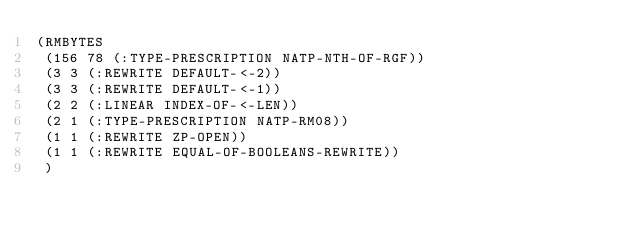Convert code to text. <code><loc_0><loc_0><loc_500><loc_500><_Lisp_>(RMBYTES
 (156 78 (:TYPE-PRESCRIPTION NATP-NTH-OF-RGF))
 (3 3 (:REWRITE DEFAULT-<-2))
 (3 3 (:REWRITE DEFAULT-<-1))
 (2 2 (:LINEAR INDEX-OF-<-LEN))
 (2 1 (:TYPE-PRESCRIPTION NATP-RM08))
 (1 1 (:REWRITE ZP-OPEN))
 (1 1 (:REWRITE EQUAL-OF-BOOLEANS-REWRITE))
 )</code> 